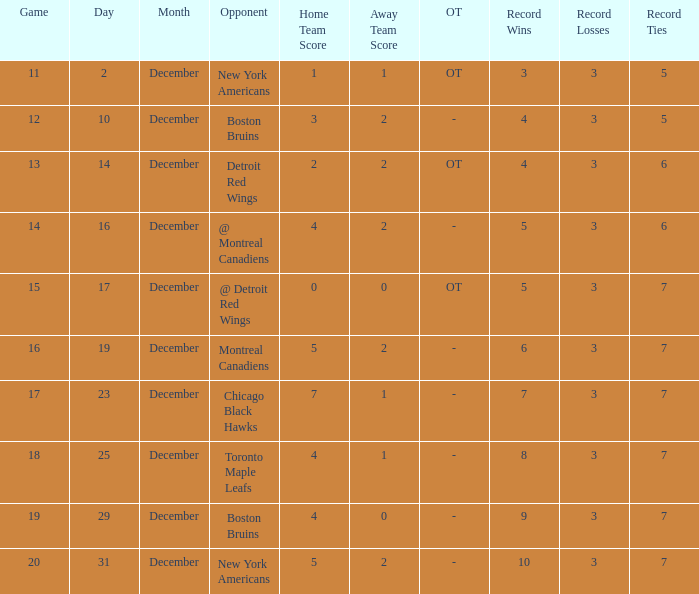Which December has a Record of 4-3-6? 14.0. 